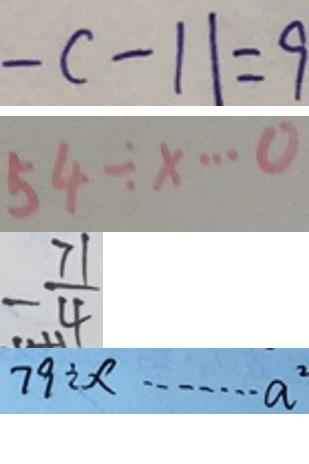Convert formula to latex. <formula><loc_0><loc_0><loc_500><loc_500>- c - 1 1 = 9 
 5 4 \div x \cdots 0 
 - \frac { 7 1 } { 4 } 
 7 9 \div x \cdots a ^ { 2 }</formula> 